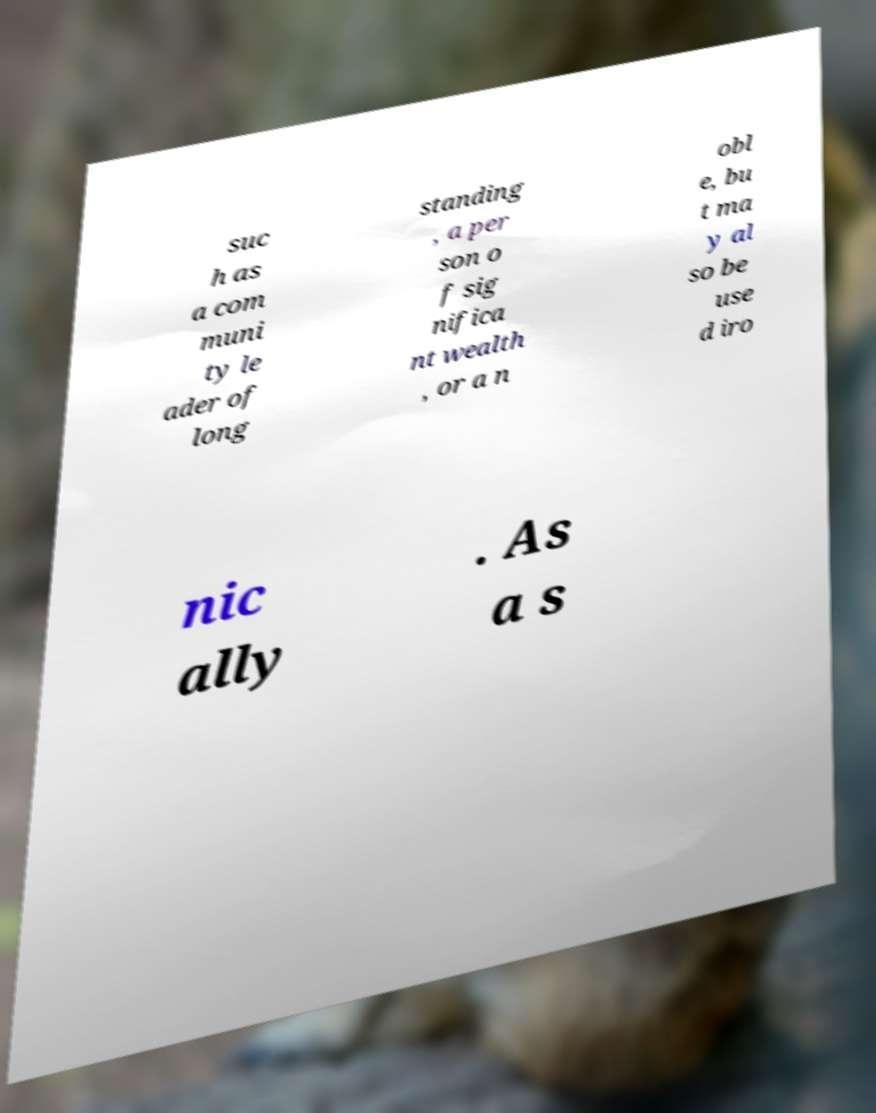There's text embedded in this image that I need extracted. Can you transcribe it verbatim? suc h as a com muni ty le ader of long standing , a per son o f sig nifica nt wealth , or a n obl e, bu t ma y al so be use d iro nic ally . As a s 